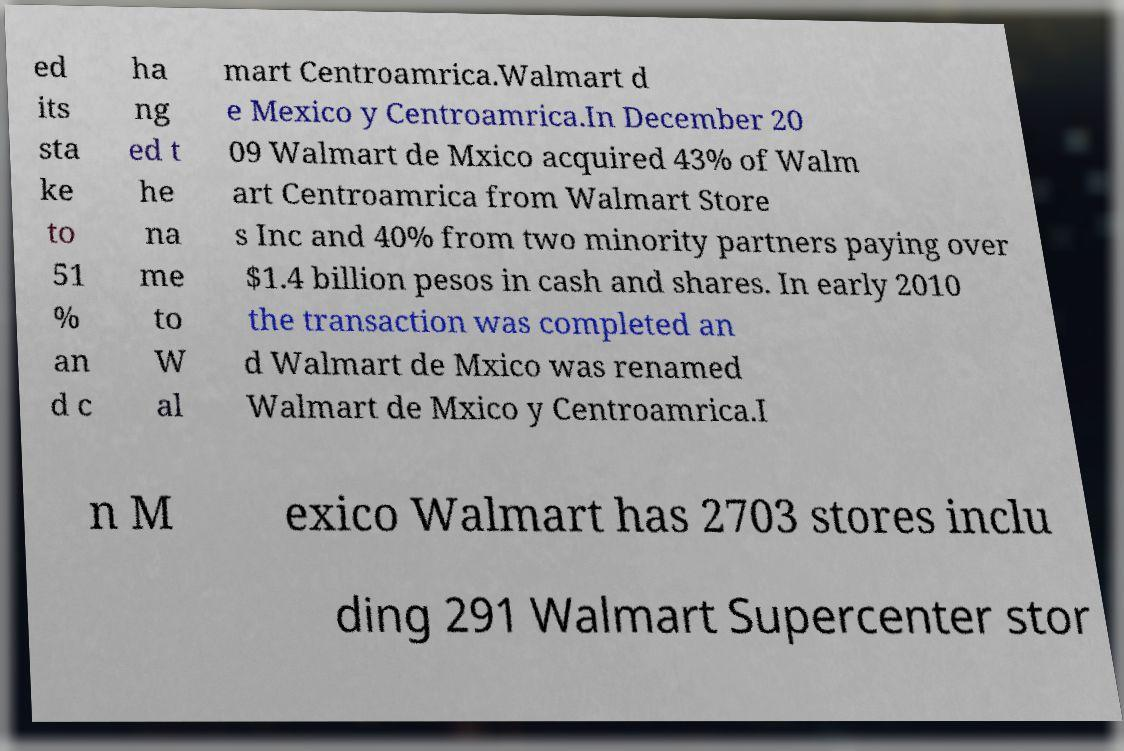What messages or text are displayed in this image? I need them in a readable, typed format. ed its sta ke to 51 % an d c ha ng ed t he na me to W al mart Centroamrica.Walmart d e Mexico y Centroamrica.In December 20 09 Walmart de Mxico acquired 43% of Walm art Centroamrica from Walmart Store s Inc and 40% from two minority partners paying over $1.4 billion pesos in cash and shares. In early 2010 the transaction was completed an d Walmart de Mxico was renamed Walmart de Mxico y Centroamrica.I n M exico Walmart has 2703 stores inclu ding 291 Walmart Supercenter stor 